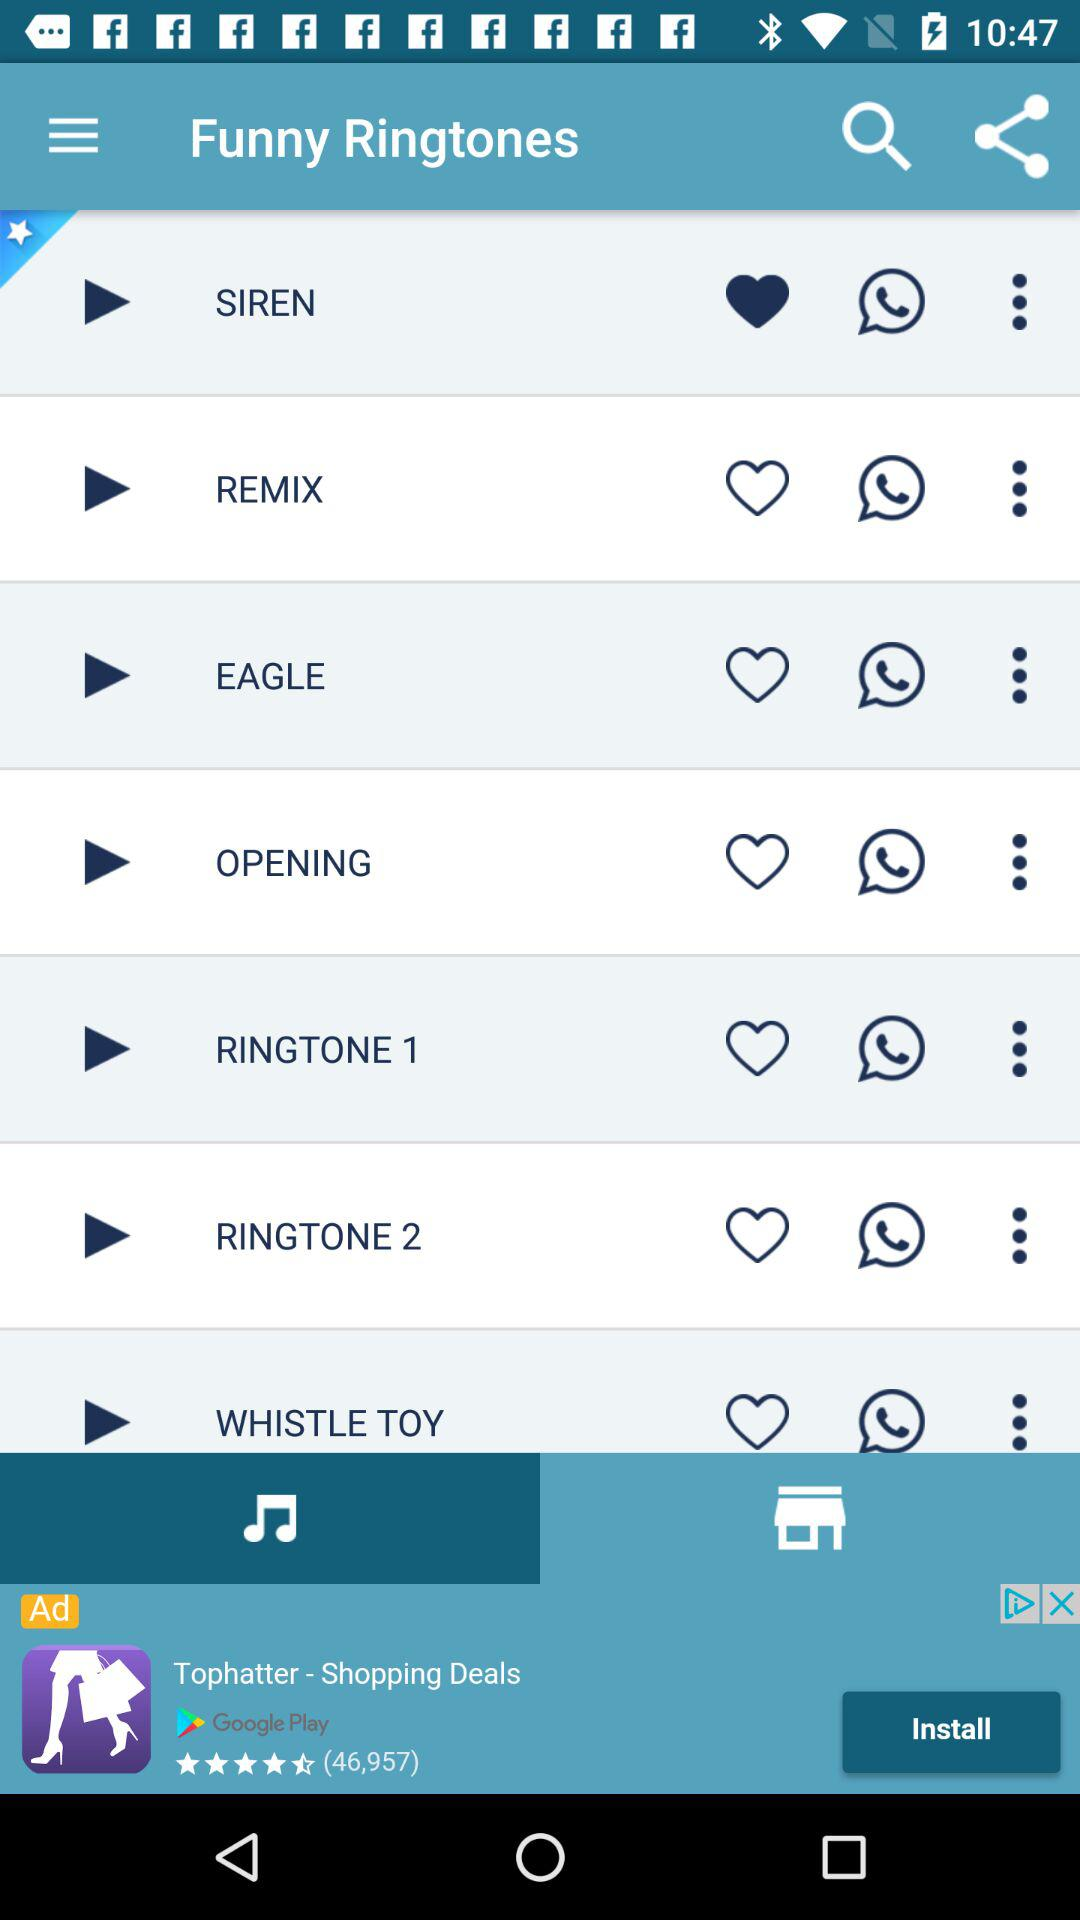Which ringtone is liked by the user? The ringtone liked by the user is "SIREN". 